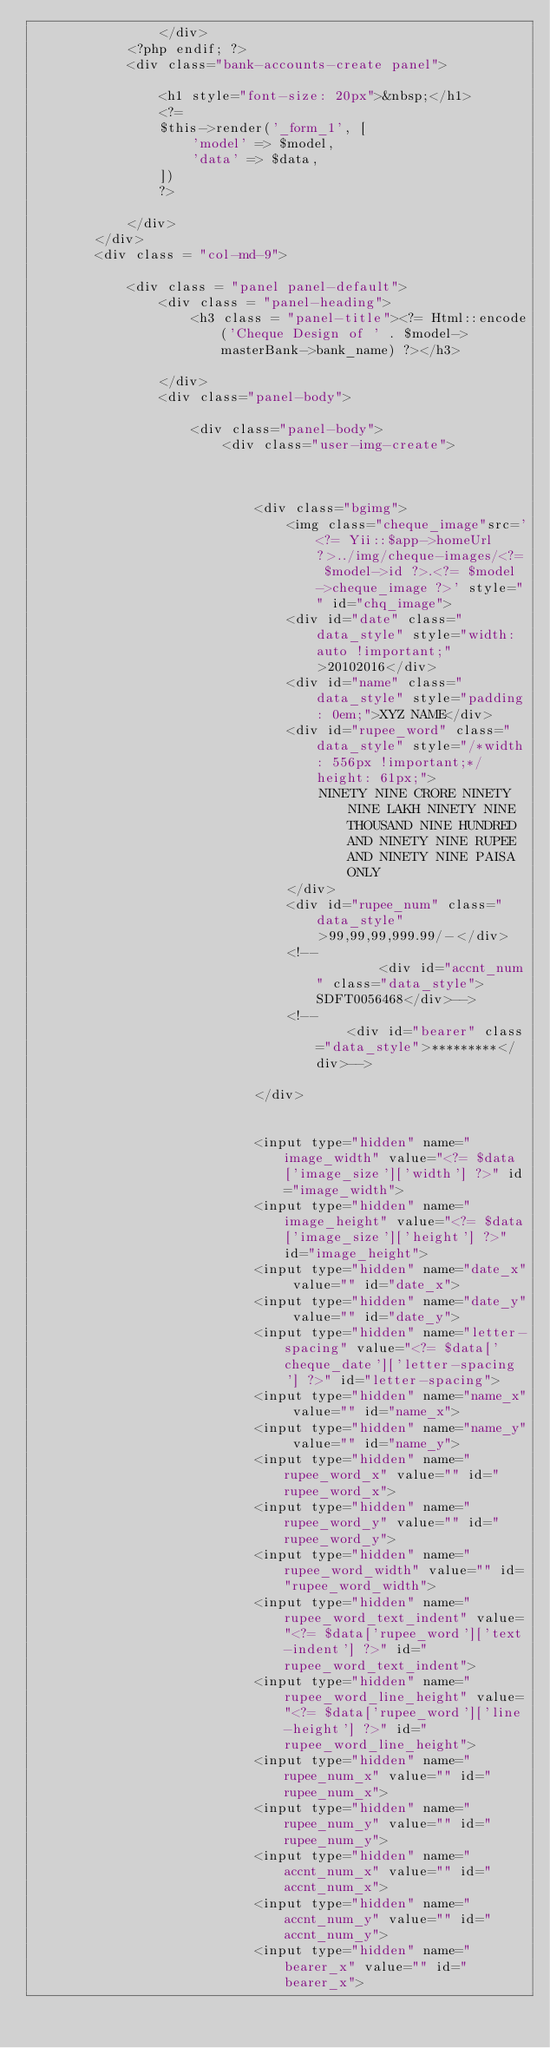Convert code to text. <code><loc_0><loc_0><loc_500><loc_500><_PHP_>				</div>
			<?php endif; ?>
			<div class="bank-accounts-create panel">

				<h1 style="font-size: 20px">&nbsp;</h1>
				<?=
				$this->render('_form_1', [
				    'model' => $model,
				    'data' => $data,
				])
				?>

			</div>
		</div>
		<div class = "col-md-9">

			<div class = "panel panel-default">
				<div class = "panel-heading">
					<h3 class = "panel-title"><?= Html::encode('Cheque Design of ' . $model->masterBank->bank_name) ?></h3>

				</div>
				<div class="panel-body">

					<div class="panel-body">
						<div class="user-img-create">



							<div class="bgimg">
								<img class="cheque_image"src='<?= Yii::$app->homeUrl ?>../img/cheque-images/<?= $model->id ?>.<?= $model->cheque_image ?>' style="" id="chq_image">
								<div id="date" class="data_style" style="width: auto !important;" >20102016</div>
								<div id="name" class="data_style" style="padding: 0em;">XYZ NAME</div>
								<div id="rupee_word" class="data_style" style="/*width: 556px !important;*/height: 61px;">
									NINETY NINE CRORE NINETY NINE LAKH NINETY NINE THOUSAND NINE HUNDRED AND NINETY NINE RUPEE AND NINETY NINE PAISA ONLY
								</div>
								<div id="rupee_num" class="data_style">99,99,99,999.99/-</div>
								<!--								<div id="accnt_num" class="data_style">SDFT0056468</div>-->
								<!--							<div id="bearer" class="data_style">*********</div>-->

							</div>


							<input type="hidden" name="image_width" value="<?= $data['image_size']['width'] ?>" id="image_width">
							<input type="hidden" name="image_height" value="<?= $data['image_size']['height'] ?>" id="image_height">
							<input type="hidden" name="date_x" value="" id="date_x">
							<input type="hidden" name="date_y" value="" id="date_y">
							<input type="hidden" name="letter-spacing" value="<?= $data['cheque_date']['letter-spacing'] ?>" id="letter-spacing">
							<input type="hidden" name="name_x" value="" id="name_x">
							<input type="hidden" name="name_y" value="" id="name_y">
							<input type="hidden" name="rupee_word_x" value="" id="rupee_word_x">
							<input type="hidden" name="rupee_word_y" value="" id="rupee_word_y">
							<input type="hidden" name="rupee_word_width" value="" id="rupee_word_width">
							<input type="hidden" name="rupee_word_text_indent" value="<?= $data['rupee_word']['text-indent'] ?>" id="rupee_word_text_indent">
							<input type="hidden" name="rupee_word_line_height" value="<?= $data['rupee_word']['line-height'] ?>" id="rupee_word_line_height">
							<input type="hidden" name="rupee_num_x" value="" id="rupee_num_x">
							<input type="hidden" name="rupee_num_y" value="" id="rupee_num_y">
							<input type="hidden" name="accnt_num_x" value="" id="accnt_num_x">
							<input type="hidden" name="accnt_num_y" value="" id="accnt_num_y">
							<input type="hidden" name="bearer_x" value="" id="bearer_x"></code> 